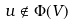<formula> <loc_0><loc_0><loc_500><loc_500>u \notin \Phi ( V )</formula> 